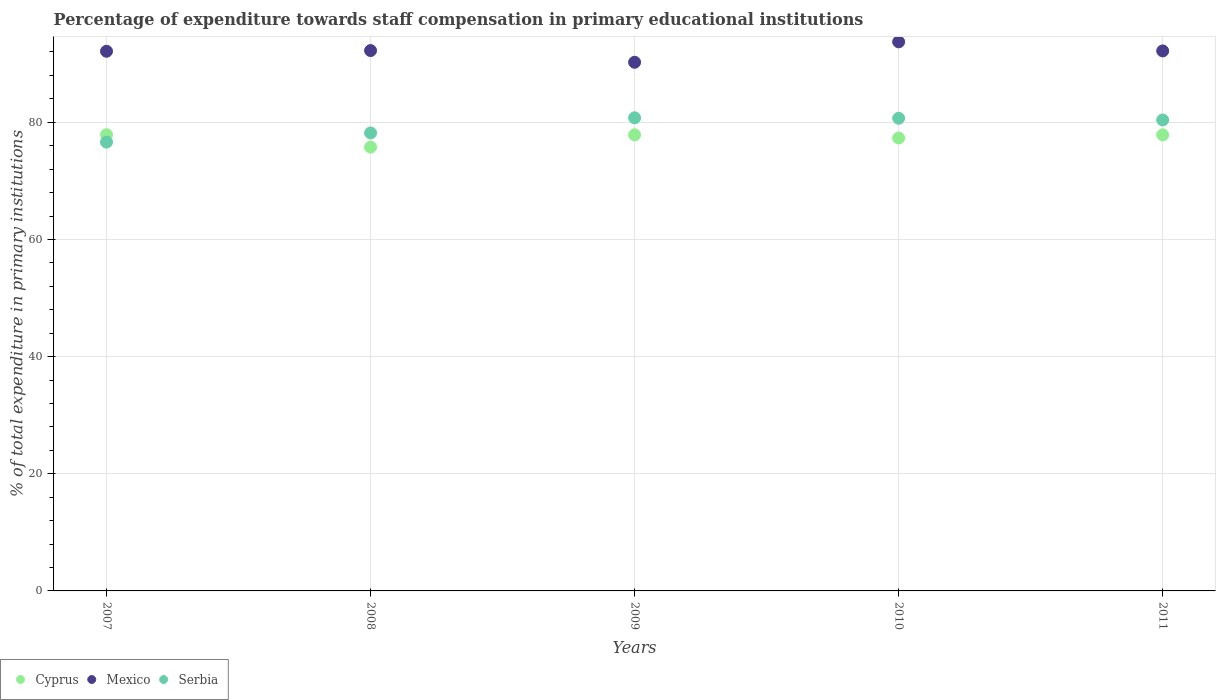What is the percentage of expenditure towards staff compensation in Mexico in 2010?
Provide a succinct answer. 93.73. Across all years, what is the maximum percentage of expenditure towards staff compensation in Cyprus?
Make the answer very short. 77.88. Across all years, what is the minimum percentage of expenditure towards staff compensation in Mexico?
Offer a terse response. 90.24. In which year was the percentage of expenditure towards staff compensation in Cyprus minimum?
Ensure brevity in your answer.  2008. What is the total percentage of expenditure towards staff compensation in Mexico in the graph?
Make the answer very short. 460.52. What is the difference between the percentage of expenditure towards staff compensation in Mexico in 2008 and that in 2009?
Your response must be concise. 2. What is the difference between the percentage of expenditure towards staff compensation in Cyprus in 2011 and the percentage of expenditure towards staff compensation in Serbia in 2008?
Offer a very short reply. -0.33. What is the average percentage of expenditure towards staff compensation in Cyprus per year?
Your answer should be compact. 77.33. In the year 2007, what is the difference between the percentage of expenditure towards staff compensation in Serbia and percentage of expenditure towards staff compensation in Cyprus?
Your answer should be compact. -1.27. What is the ratio of the percentage of expenditure towards staff compensation in Serbia in 2010 to that in 2011?
Your answer should be very brief. 1. Is the percentage of expenditure towards staff compensation in Serbia in 2008 less than that in 2009?
Keep it short and to the point. Yes. Is the difference between the percentage of expenditure towards staff compensation in Serbia in 2007 and 2009 greater than the difference between the percentage of expenditure towards staff compensation in Cyprus in 2007 and 2009?
Your answer should be very brief. No. What is the difference between the highest and the second highest percentage of expenditure towards staff compensation in Cyprus?
Provide a succinct answer. 0.02. What is the difference between the highest and the lowest percentage of expenditure towards staff compensation in Cyprus?
Provide a succinct answer. 2.12. In how many years, is the percentage of expenditure towards staff compensation in Cyprus greater than the average percentage of expenditure towards staff compensation in Cyprus taken over all years?
Ensure brevity in your answer.  3. Is it the case that in every year, the sum of the percentage of expenditure towards staff compensation in Serbia and percentage of expenditure towards staff compensation in Cyprus  is greater than the percentage of expenditure towards staff compensation in Mexico?
Keep it short and to the point. Yes. Is the percentage of expenditure towards staff compensation in Mexico strictly greater than the percentage of expenditure towards staff compensation in Cyprus over the years?
Keep it short and to the point. Yes. Is the percentage of expenditure towards staff compensation in Serbia strictly less than the percentage of expenditure towards staff compensation in Cyprus over the years?
Provide a short and direct response. No. How many years are there in the graph?
Provide a short and direct response. 5. Are the values on the major ticks of Y-axis written in scientific E-notation?
Your answer should be compact. No. Does the graph contain grids?
Offer a terse response. Yes. Where does the legend appear in the graph?
Make the answer very short. Bottom left. How are the legend labels stacked?
Offer a terse response. Horizontal. What is the title of the graph?
Offer a very short reply. Percentage of expenditure towards staff compensation in primary educational institutions. Does "New Zealand" appear as one of the legend labels in the graph?
Make the answer very short. No. What is the label or title of the Y-axis?
Your answer should be very brief. % of total expenditure in primary institutions. What is the % of total expenditure in primary institutions of Cyprus in 2007?
Ensure brevity in your answer.  77.88. What is the % of total expenditure in primary institutions of Mexico in 2007?
Give a very brief answer. 92.12. What is the % of total expenditure in primary institutions of Serbia in 2007?
Your response must be concise. 76.61. What is the % of total expenditure in primary institutions of Cyprus in 2008?
Make the answer very short. 75.76. What is the % of total expenditure in primary institutions of Mexico in 2008?
Offer a very short reply. 92.24. What is the % of total expenditure in primary institutions in Serbia in 2008?
Your answer should be compact. 78.18. What is the % of total expenditure in primary institutions of Cyprus in 2009?
Give a very brief answer. 77.86. What is the % of total expenditure in primary institutions in Mexico in 2009?
Your answer should be compact. 90.24. What is the % of total expenditure in primary institutions of Serbia in 2009?
Provide a succinct answer. 80.76. What is the % of total expenditure in primary institutions of Cyprus in 2010?
Make the answer very short. 77.32. What is the % of total expenditure in primary institutions in Mexico in 2010?
Make the answer very short. 93.73. What is the % of total expenditure in primary institutions of Serbia in 2010?
Your response must be concise. 80.69. What is the % of total expenditure in primary institutions in Cyprus in 2011?
Provide a succinct answer. 77.85. What is the % of total expenditure in primary institutions of Mexico in 2011?
Give a very brief answer. 92.18. What is the % of total expenditure in primary institutions of Serbia in 2011?
Your answer should be compact. 80.39. Across all years, what is the maximum % of total expenditure in primary institutions of Cyprus?
Your answer should be very brief. 77.88. Across all years, what is the maximum % of total expenditure in primary institutions in Mexico?
Make the answer very short. 93.73. Across all years, what is the maximum % of total expenditure in primary institutions in Serbia?
Offer a very short reply. 80.76. Across all years, what is the minimum % of total expenditure in primary institutions of Cyprus?
Your response must be concise. 75.76. Across all years, what is the minimum % of total expenditure in primary institutions in Mexico?
Give a very brief answer. 90.24. Across all years, what is the minimum % of total expenditure in primary institutions in Serbia?
Your answer should be compact. 76.61. What is the total % of total expenditure in primary institutions of Cyprus in the graph?
Your response must be concise. 386.66. What is the total % of total expenditure in primary institutions of Mexico in the graph?
Your answer should be compact. 460.52. What is the total % of total expenditure in primary institutions of Serbia in the graph?
Offer a very short reply. 396.63. What is the difference between the % of total expenditure in primary institutions of Cyprus in 2007 and that in 2008?
Offer a very short reply. 2.12. What is the difference between the % of total expenditure in primary institutions of Mexico in 2007 and that in 2008?
Keep it short and to the point. -0.12. What is the difference between the % of total expenditure in primary institutions in Serbia in 2007 and that in 2008?
Provide a short and direct response. -1.56. What is the difference between the % of total expenditure in primary institutions in Cyprus in 2007 and that in 2009?
Your answer should be compact. 0.02. What is the difference between the % of total expenditure in primary institutions of Mexico in 2007 and that in 2009?
Provide a short and direct response. 1.88. What is the difference between the % of total expenditure in primary institutions of Serbia in 2007 and that in 2009?
Keep it short and to the point. -4.15. What is the difference between the % of total expenditure in primary institutions in Cyprus in 2007 and that in 2010?
Your answer should be compact. 0.56. What is the difference between the % of total expenditure in primary institutions in Mexico in 2007 and that in 2010?
Your response must be concise. -1.61. What is the difference between the % of total expenditure in primary institutions of Serbia in 2007 and that in 2010?
Give a very brief answer. -4.07. What is the difference between the % of total expenditure in primary institutions of Cyprus in 2007 and that in 2011?
Keep it short and to the point. 0.03. What is the difference between the % of total expenditure in primary institutions of Mexico in 2007 and that in 2011?
Your answer should be very brief. -0.06. What is the difference between the % of total expenditure in primary institutions in Serbia in 2007 and that in 2011?
Your answer should be very brief. -3.78. What is the difference between the % of total expenditure in primary institutions in Cyprus in 2008 and that in 2009?
Offer a very short reply. -2.09. What is the difference between the % of total expenditure in primary institutions of Mexico in 2008 and that in 2009?
Keep it short and to the point. 2. What is the difference between the % of total expenditure in primary institutions in Serbia in 2008 and that in 2009?
Make the answer very short. -2.59. What is the difference between the % of total expenditure in primary institutions in Cyprus in 2008 and that in 2010?
Give a very brief answer. -1.56. What is the difference between the % of total expenditure in primary institutions of Mexico in 2008 and that in 2010?
Offer a terse response. -1.49. What is the difference between the % of total expenditure in primary institutions of Serbia in 2008 and that in 2010?
Offer a very short reply. -2.51. What is the difference between the % of total expenditure in primary institutions of Cyprus in 2008 and that in 2011?
Offer a terse response. -2.09. What is the difference between the % of total expenditure in primary institutions in Mexico in 2008 and that in 2011?
Provide a succinct answer. 0.06. What is the difference between the % of total expenditure in primary institutions in Serbia in 2008 and that in 2011?
Your answer should be very brief. -2.22. What is the difference between the % of total expenditure in primary institutions in Cyprus in 2009 and that in 2010?
Your response must be concise. 0.54. What is the difference between the % of total expenditure in primary institutions in Mexico in 2009 and that in 2010?
Your answer should be very brief. -3.49. What is the difference between the % of total expenditure in primary institutions in Serbia in 2009 and that in 2010?
Make the answer very short. 0.08. What is the difference between the % of total expenditure in primary institutions of Cyprus in 2009 and that in 2011?
Your answer should be very brief. 0.01. What is the difference between the % of total expenditure in primary institutions of Mexico in 2009 and that in 2011?
Your answer should be compact. -1.94. What is the difference between the % of total expenditure in primary institutions in Serbia in 2009 and that in 2011?
Your answer should be compact. 0.37. What is the difference between the % of total expenditure in primary institutions in Cyprus in 2010 and that in 2011?
Offer a very short reply. -0.53. What is the difference between the % of total expenditure in primary institutions of Mexico in 2010 and that in 2011?
Keep it short and to the point. 1.55. What is the difference between the % of total expenditure in primary institutions in Serbia in 2010 and that in 2011?
Provide a short and direct response. 0.29. What is the difference between the % of total expenditure in primary institutions in Cyprus in 2007 and the % of total expenditure in primary institutions in Mexico in 2008?
Provide a short and direct response. -14.36. What is the difference between the % of total expenditure in primary institutions of Cyprus in 2007 and the % of total expenditure in primary institutions of Serbia in 2008?
Provide a short and direct response. -0.3. What is the difference between the % of total expenditure in primary institutions in Mexico in 2007 and the % of total expenditure in primary institutions in Serbia in 2008?
Your answer should be compact. 13.94. What is the difference between the % of total expenditure in primary institutions in Cyprus in 2007 and the % of total expenditure in primary institutions in Mexico in 2009?
Make the answer very short. -12.37. What is the difference between the % of total expenditure in primary institutions in Cyprus in 2007 and the % of total expenditure in primary institutions in Serbia in 2009?
Provide a succinct answer. -2.89. What is the difference between the % of total expenditure in primary institutions in Mexico in 2007 and the % of total expenditure in primary institutions in Serbia in 2009?
Provide a succinct answer. 11.36. What is the difference between the % of total expenditure in primary institutions in Cyprus in 2007 and the % of total expenditure in primary institutions in Mexico in 2010?
Offer a very short reply. -15.85. What is the difference between the % of total expenditure in primary institutions in Cyprus in 2007 and the % of total expenditure in primary institutions in Serbia in 2010?
Offer a very short reply. -2.81. What is the difference between the % of total expenditure in primary institutions of Mexico in 2007 and the % of total expenditure in primary institutions of Serbia in 2010?
Keep it short and to the point. 11.43. What is the difference between the % of total expenditure in primary institutions of Cyprus in 2007 and the % of total expenditure in primary institutions of Mexico in 2011?
Make the answer very short. -14.3. What is the difference between the % of total expenditure in primary institutions in Cyprus in 2007 and the % of total expenditure in primary institutions in Serbia in 2011?
Keep it short and to the point. -2.52. What is the difference between the % of total expenditure in primary institutions in Mexico in 2007 and the % of total expenditure in primary institutions in Serbia in 2011?
Offer a terse response. 11.73. What is the difference between the % of total expenditure in primary institutions in Cyprus in 2008 and the % of total expenditure in primary institutions in Mexico in 2009?
Give a very brief answer. -14.48. What is the difference between the % of total expenditure in primary institutions of Cyprus in 2008 and the % of total expenditure in primary institutions of Serbia in 2009?
Offer a terse response. -5. What is the difference between the % of total expenditure in primary institutions of Mexico in 2008 and the % of total expenditure in primary institutions of Serbia in 2009?
Provide a short and direct response. 11.48. What is the difference between the % of total expenditure in primary institutions in Cyprus in 2008 and the % of total expenditure in primary institutions in Mexico in 2010?
Your answer should be compact. -17.97. What is the difference between the % of total expenditure in primary institutions in Cyprus in 2008 and the % of total expenditure in primary institutions in Serbia in 2010?
Ensure brevity in your answer.  -4.93. What is the difference between the % of total expenditure in primary institutions of Mexico in 2008 and the % of total expenditure in primary institutions of Serbia in 2010?
Offer a terse response. 11.55. What is the difference between the % of total expenditure in primary institutions in Cyprus in 2008 and the % of total expenditure in primary institutions in Mexico in 2011?
Offer a terse response. -16.42. What is the difference between the % of total expenditure in primary institutions in Cyprus in 2008 and the % of total expenditure in primary institutions in Serbia in 2011?
Offer a very short reply. -4.63. What is the difference between the % of total expenditure in primary institutions of Mexico in 2008 and the % of total expenditure in primary institutions of Serbia in 2011?
Your answer should be very brief. 11.85. What is the difference between the % of total expenditure in primary institutions in Cyprus in 2009 and the % of total expenditure in primary institutions in Mexico in 2010?
Make the answer very short. -15.88. What is the difference between the % of total expenditure in primary institutions of Cyprus in 2009 and the % of total expenditure in primary institutions of Serbia in 2010?
Provide a succinct answer. -2.83. What is the difference between the % of total expenditure in primary institutions in Mexico in 2009 and the % of total expenditure in primary institutions in Serbia in 2010?
Give a very brief answer. 9.56. What is the difference between the % of total expenditure in primary institutions in Cyprus in 2009 and the % of total expenditure in primary institutions in Mexico in 2011?
Give a very brief answer. -14.33. What is the difference between the % of total expenditure in primary institutions of Cyprus in 2009 and the % of total expenditure in primary institutions of Serbia in 2011?
Provide a short and direct response. -2.54. What is the difference between the % of total expenditure in primary institutions in Mexico in 2009 and the % of total expenditure in primary institutions in Serbia in 2011?
Offer a very short reply. 9.85. What is the difference between the % of total expenditure in primary institutions of Cyprus in 2010 and the % of total expenditure in primary institutions of Mexico in 2011?
Provide a succinct answer. -14.86. What is the difference between the % of total expenditure in primary institutions of Cyprus in 2010 and the % of total expenditure in primary institutions of Serbia in 2011?
Provide a succinct answer. -3.08. What is the difference between the % of total expenditure in primary institutions in Mexico in 2010 and the % of total expenditure in primary institutions in Serbia in 2011?
Your response must be concise. 13.34. What is the average % of total expenditure in primary institutions in Cyprus per year?
Your response must be concise. 77.33. What is the average % of total expenditure in primary institutions in Mexico per year?
Offer a terse response. 92.1. What is the average % of total expenditure in primary institutions in Serbia per year?
Offer a terse response. 79.33. In the year 2007, what is the difference between the % of total expenditure in primary institutions in Cyprus and % of total expenditure in primary institutions in Mexico?
Ensure brevity in your answer.  -14.24. In the year 2007, what is the difference between the % of total expenditure in primary institutions of Cyprus and % of total expenditure in primary institutions of Serbia?
Your answer should be very brief. 1.27. In the year 2007, what is the difference between the % of total expenditure in primary institutions of Mexico and % of total expenditure in primary institutions of Serbia?
Your response must be concise. 15.51. In the year 2008, what is the difference between the % of total expenditure in primary institutions of Cyprus and % of total expenditure in primary institutions of Mexico?
Keep it short and to the point. -16.48. In the year 2008, what is the difference between the % of total expenditure in primary institutions in Cyprus and % of total expenditure in primary institutions in Serbia?
Your response must be concise. -2.42. In the year 2008, what is the difference between the % of total expenditure in primary institutions of Mexico and % of total expenditure in primary institutions of Serbia?
Make the answer very short. 14.06. In the year 2009, what is the difference between the % of total expenditure in primary institutions of Cyprus and % of total expenditure in primary institutions of Mexico?
Your answer should be very brief. -12.39. In the year 2009, what is the difference between the % of total expenditure in primary institutions of Cyprus and % of total expenditure in primary institutions of Serbia?
Your answer should be very brief. -2.91. In the year 2009, what is the difference between the % of total expenditure in primary institutions of Mexico and % of total expenditure in primary institutions of Serbia?
Keep it short and to the point. 9.48. In the year 2010, what is the difference between the % of total expenditure in primary institutions in Cyprus and % of total expenditure in primary institutions in Mexico?
Offer a very short reply. -16.42. In the year 2010, what is the difference between the % of total expenditure in primary institutions in Cyprus and % of total expenditure in primary institutions in Serbia?
Your response must be concise. -3.37. In the year 2010, what is the difference between the % of total expenditure in primary institutions in Mexico and % of total expenditure in primary institutions in Serbia?
Provide a short and direct response. 13.04. In the year 2011, what is the difference between the % of total expenditure in primary institutions in Cyprus and % of total expenditure in primary institutions in Mexico?
Offer a very short reply. -14.33. In the year 2011, what is the difference between the % of total expenditure in primary institutions of Cyprus and % of total expenditure in primary institutions of Serbia?
Provide a short and direct response. -2.54. In the year 2011, what is the difference between the % of total expenditure in primary institutions in Mexico and % of total expenditure in primary institutions in Serbia?
Provide a succinct answer. 11.79. What is the ratio of the % of total expenditure in primary institutions of Cyprus in 2007 to that in 2008?
Provide a short and direct response. 1.03. What is the ratio of the % of total expenditure in primary institutions in Mexico in 2007 to that in 2008?
Your response must be concise. 1. What is the ratio of the % of total expenditure in primary institutions of Serbia in 2007 to that in 2008?
Your answer should be compact. 0.98. What is the ratio of the % of total expenditure in primary institutions of Mexico in 2007 to that in 2009?
Offer a very short reply. 1.02. What is the ratio of the % of total expenditure in primary institutions in Serbia in 2007 to that in 2009?
Offer a very short reply. 0.95. What is the ratio of the % of total expenditure in primary institutions in Cyprus in 2007 to that in 2010?
Give a very brief answer. 1.01. What is the ratio of the % of total expenditure in primary institutions in Mexico in 2007 to that in 2010?
Provide a short and direct response. 0.98. What is the ratio of the % of total expenditure in primary institutions of Serbia in 2007 to that in 2010?
Your response must be concise. 0.95. What is the ratio of the % of total expenditure in primary institutions in Mexico in 2007 to that in 2011?
Keep it short and to the point. 1. What is the ratio of the % of total expenditure in primary institutions in Serbia in 2007 to that in 2011?
Give a very brief answer. 0.95. What is the ratio of the % of total expenditure in primary institutions of Cyprus in 2008 to that in 2009?
Your answer should be very brief. 0.97. What is the ratio of the % of total expenditure in primary institutions of Mexico in 2008 to that in 2009?
Ensure brevity in your answer.  1.02. What is the ratio of the % of total expenditure in primary institutions in Cyprus in 2008 to that in 2010?
Provide a succinct answer. 0.98. What is the ratio of the % of total expenditure in primary institutions in Mexico in 2008 to that in 2010?
Provide a short and direct response. 0.98. What is the ratio of the % of total expenditure in primary institutions of Serbia in 2008 to that in 2010?
Provide a succinct answer. 0.97. What is the ratio of the % of total expenditure in primary institutions in Cyprus in 2008 to that in 2011?
Provide a short and direct response. 0.97. What is the ratio of the % of total expenditure in primary institutions of Serbia in 2008 to that in 2011?
Make the answer very short. 0.97. What is the ratio of the % of total expenditure in primary institutions in Cyprus in 2009 to that in 2010?
Offer a terse response. 1.01. What is the ratio of the % of total expenditure in primary institutions in Mexico in 2009 to that in 2010?
Provide a short and direct response. 0.96. What is the ratio of the % of total expenditure in primary institutions in Serbia in 2009 to that in 2010?
Offer a terse response. 1. What is the ratio of the % of total expenditure in primary institutions of Cyprus in 2009 to that in 2011?
Keep it short and to the point. 1. What is the ratio of the % of total expenditure in primary institutions in Mexico in 2009 to that in 2011?
Give a very brief answer. 0.98. What is the ratio of the % of total expenditure in primary institutions in Mexico in 2010 to that in 2011?
Ensure brevity in your answer.  1.02. What is the ratio of the % of total expenditure in primary institutions of Serbia in 2010 to that in 2011?
Ensure brevity in your answer.  1. What is the difference between the highest and the second highest % of total expenditure in primary institutions in Cyprus?
Provide a succinct answer. 0.02. What is the difference between the highest and the second highest % of total expenditure in primary institutions of Mexico?
Give a very brief answer. 1.49. What is the difference between the highest and the second highest % of total expenditure in primary institutions in Serbia?
Offer a very short reply. 0.08. What is the difference between the highest and the lowest % of total expenditure in primary institutions in Cyprus?
Your answer should be compact. 2.12. What is the difference between the highest and the lowest % of total expenditure in primary institutions of Mexico?
Provide a short and direct response. 3.49. What is the difference between the highest and the lowest % of total expenditure in primary institutions of Serbia?
Offer a terse response. 4.15. 